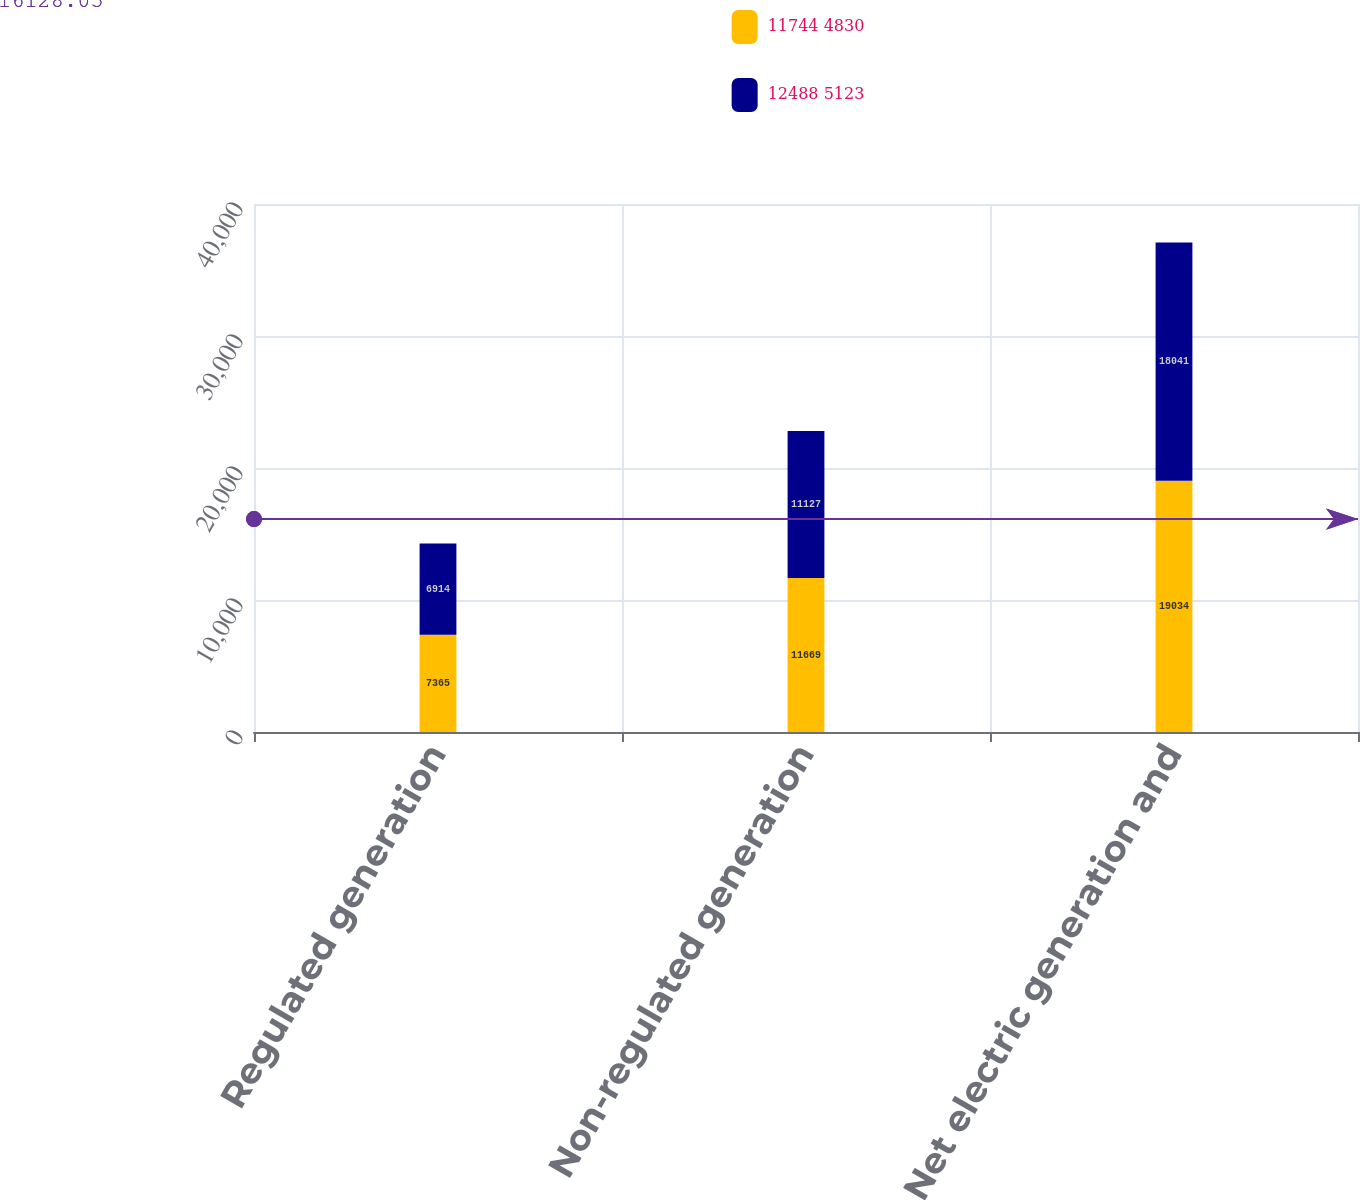Convert chart to OTSL. <chart><loc_0><loc_0><loc_500><loc_500><stacked_bar_chart><ecel><fcel>Regulated generation<fcel>Non-regulated generation<fcel>Net electric generation and<nl><fcel>11744 4830<fcel>7365<fcel>11669<fcel>19034<nl><fcel>12488 5123<fcel>6914<fcel>11127<fcel>18041<nl></chart> 